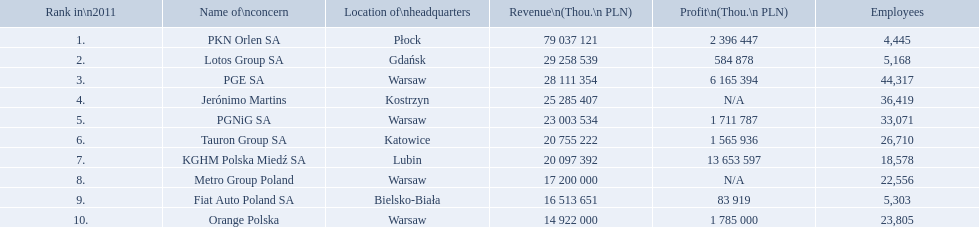Which concern's headquarters are located in warsaw? PGE SA, PGNiG SA, Metro Group Poland. Which of these listed a profit? PGE SA, PGNiG SA. Of these how many employees are in the concern with the lowest profit? 33,071. What are the names of all the concerns? PKN Orlen SA, Lotos Group SA, PGE SA, Jerónimo Martins, PGNiG SA, Tauron Group SA, KGHM Polska Miedź SA, Metro Group Poland, Fiat Auto Poland SA, Orange Polska. How many employees does pgnig sa have? 33,071. Can you give me this table in json format? {'header': ['Rank in\\n2011', 'Name of\\nconcern', 'Location of\\nheadquarters', 'Revenue\\n(Thou.\\n\xa0PLN)', 'Profit\\n(Thou.\\n\xa0PLN)', 'Employees'], 'rows': [['1.', 'PKN Orlen SA', 'Płock', '79 037 121', '2 396 447', '4,445'], ['2.', 'Lotos Group SA', 'Gdańsk', '29 258 539', '584 878', '5,168'], ['3.', 'PGE SA', 'Warsaw', '28 111 354', '6 165 394', '44,317'], ['4.', 'Jerónimo Martins', 'Kostrzyn', '25 285 407', 'N/A', '36,419'], ['5.', 'PGNiG SA', 'Warsaw', '23 003 534', '1 711 787', '33,071'], ['6.', 'Tauron Group SA', 'Katowice', '20 755 222', '1 565 936', '26,710'], ['7.', 'KGHM Polska Miedź SA', 'Lubin', '20 097 392', '13 653 597', '18,578'], ['8.', 'Metro Group Poland', 'Warsaw', '17 200 000', 'N/A', '22,556'], ['9.', 'Fiat Auto Poland SA', 'Bielsko-Biała', '16 513 651', '83 919', '5,303'], ['10.', 'Orange Polska', 'Warsaw', '14 922 000', '1 785 000', '23,805']]} What are the labels for all the issues? PKN Orlen SA, Lotos Group SA, PGE SA, Jerónimo Martins, PGNiG SA, Tauron Group SA, KGHM Polska Miedź SA, Metro Group Poland, Fiat Auto Poland SA, Orange Polska. How many personnel does pgnig sa consist of? 33,071. Can you give me this table as a dict? {'header': ['Rank in\\n2011', 'Name of\\nconcern', 'Location of\\nheadquarters', 'Revenue\\n(Thou.\\n\xa0PLN)', 'Profit\\n(Thou.\\n\xa0PLN)', 'Employees'], 'rows': [['1.', 'PKN Orlen SA', 'Płock', '79 037 121', '2 396 447', '4,445'], ['2.', 'Lotos Group SA', 'Gdańsk', '29 258 539', '584 878', '5,168'], ['3.', 'PGE SA', 'Warsaw', '28 111 354', '6 165 394', '44,317'], ['4.', 'Jerónimo Martins', 'Kostrzyn', '25 285 407', 'N/A', '36,419'], ['5.', 'PGNiG SA', 'Warsaw', '23 003 534', '1 711 787', '33,071'], ['6.', 'Tauron Group SA', 'Katowice', '20 755 222', '1 565 936', '26,710'], ['7.', 'KGHM Polska Miedź SA', 'Lubin', '20 097 392', '13 653 597', '18,578'], ['8.', 'Metro Group Poland', 'Warsaw', '17 200 000', 'N/A', '22,556'], ['9.', 'Fiat Auto Poland SA', 'Bielsko-Biała', '16 513 651', '83 919', '5,303'], ['10.', 'Orange Polska', 'Warsaw', '14 922 000', '1 785 000', '23,805']]} What are the appellations of the significant corporations in poland? PKN Orlen SA, Lotos Group SA, PGE SA, Jerónimo Martins, PGNiG SA, Tauron Group SA, KGHM Polska Miedź SA, Metro Group Poland, Fiat Auto Poland SA, Orange Polska. What are the incomes of these corporations in thou. pln? PKN Orlen SA, 79 037 121, Lotos Group SA, 29 258 539, PGE SA, 28 111 354, Jerónimo Martins, 25 285 407, PGNiG SA, 23 003 534, Tauron Group SA, 20 755 222, KGHM Polska Miedź SA, 20 097 392, Metro Group Poland, 17 200 000, Fiat Auto Poland SA, 16 513 651, Orange Polska, 14 922 000. Which of these incomes exceeds 75,000,000 thou. pln? 79 037 121. Which corporation possesses an income equivalent to 79,037,121 thou pln? PKN Orlen SA. What are the designations of the primary firms in poland? PKN Orlen SA, Lotos Group SA, PGE SA, Jerónimo Martins, PGNiG SA, Tauron Group SA, KGHM Polska Miedź SA, Metro Group Poland, Fiat Auto Poland SA, Orange Polska. What are the earnings of these firms in thou. pln? PKN Orlen SA, 79 037 121, Lotos Group SA, 29 258 539, PGE SA, 28 111 354, Jerónimo Martins, 25 285 407, PGNiG SA, 23 003 534, Tauron Group SA, 20 755 222, KGHM Polska Miedź SA, 20 097 392, Metro Group Poland, 17 200 000, Fiat Auto Poland SA, 16 513 651, Orange Polska, 14 922 000. Which of these earnings is more than 75,000,000 thou. pln? 79 037 121. Which firm has an earning equal to 79,037,121 thou pln? PKN Orlen SA. What are the titles of the leading enterprises in poland? PKN Orlen SA, Lotos Group SA, PGE SA, Jerónimo Martins, PGNiG SA, Tauron Group SA, KGHM Polska Miedź SA, Metro Group Poland, Fiat Auto Poland SA, Orange Polska. What are the turnovers of these enterprises in thou. pln? PKN Orlen SA, 79 037 121, Lotos Group SA, 29 258 539, PGE SA, 28 111 354, Jerónimo Martins, 25 285 407, PGNiG SA, 23 003 534, Tauron Group SA, 20 755 222, KGHM Polska Miedź SA, 20 097 392, Metro Group Poland, 17 200 000, Fiat Auto Poland SA, 16 513 651, Orange Polska, 14 922 000. Which of these turnovers is larger than 75,000,000 thou. pln? 79 037 121. Which enterprise holds a turnover corresponding to 79,037,121 thou pln? PKN Orlen SA. Which organization's main office is situated in warsaw? PGE SA, PGNiG SA, Metro Group Poland. Which of these mentioned made a profit? PGE SA, PGNiG SA. Of these, how many workers are in the entity with the lowest profit? 33,071. Which businesses are included in the list? PKN Orlen SA, Lotos Group SA, PGE SA, Jerónimo Martins, PGNiG SA, Tauron Group SA, KGHM Polska Miedź SA, Metro Group Poland, Fiat Auto Poland SA, Orange Polska. What is the income generated by these companies? 79 037 121, 29 258 539, 28 111 354, 25 285 407, 23 003 534, 20 755 222, 20 097 392, 17 200 000, 16 513 651, 14 922 000. Which business earns the highest revenue? PKN Orlen SA. What are the names of the companies listed? PKN Orlen SA, Lotos Group SA, PGE SA, Jerónimo Martins, PGNiG SA, Tauron Group SA, KGHM Polska Miedź SA, Metro Group Poland, Fiat Auto Poland SA, Orange Polska. What are their respective earnings? 79 037 121, 29 258 539, 28 111 354, 25 285 407, 23 003 534, 20 755 222, 20 097 392, 17 200 000, 16 513 651, 14 922 000. Which of these companies has the highest revenue? PKN Orlen SA. Which company's main office can be found in warsaw? PGE SA, PGNiG SA, Metro Group Poland. Among these, which ones reported a profit? PGE SA, PGNiG SA. From those, how many workers does the one with the least profit have? 33,071. 